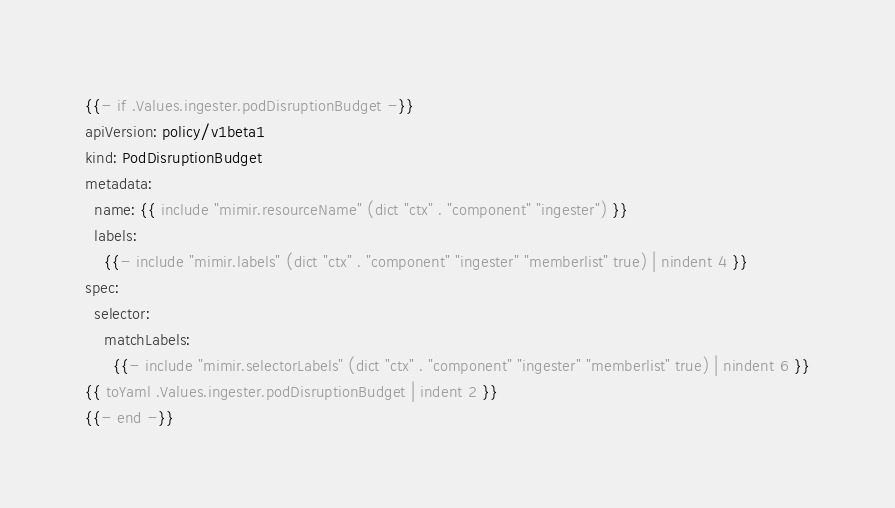Convert code to text. <code><loc_0><loc_0><loc_500><loc_500><_YAML_>{{- if .Values.ingester.podDisruptionBudget -}}
apiVersion: policy/v1beta1
kind: PodDisruptionBudget
metadata:
  name: {{ include "mimir.resourceName" (dict "ctx" . "component" "ingester") }}
  labels:
    {{- include "mimir.labels" (dict "ctx" . "component" "ingester" "memberlist" true) | nindent 4 }}
spec:
  selector:
    matchLabels:
      {{- include "mimir.selectorLabels" (dict "ctx" . "component" "ingester" "memberlist" true) | nindent 6 }}
{{ toYaml .Values.ingester.podDisruptionBudget | indent 2 }}
{{- end -}}
</code> 